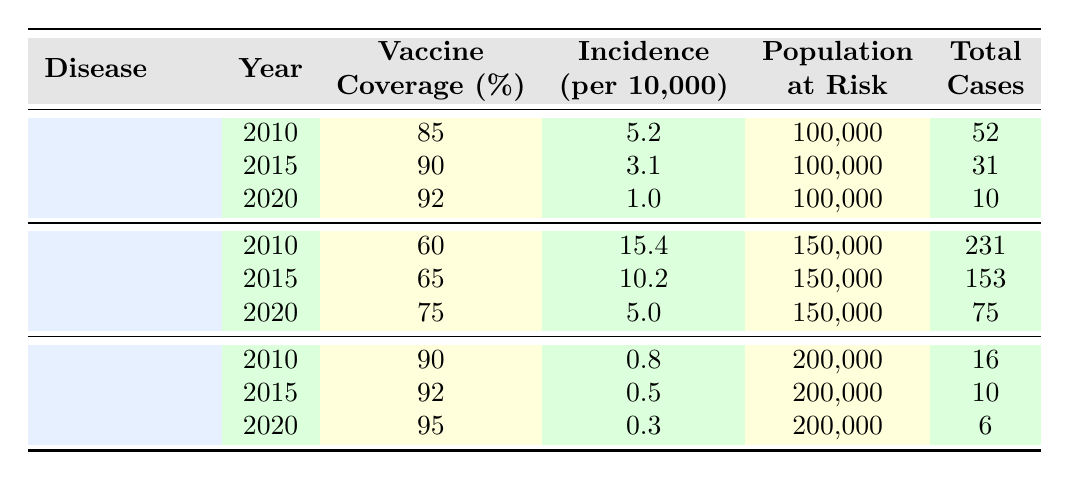What's the total number of measles cases in 2015? From the table, we can directly look at the row for measles in the year 2015, where we find the total cases listed as 31.
Answer: 31 What was the vaccine coverage percentage for influenza in 2020? The table indicates that the vaccine coverage percentage for influenza in 2020 is 75, as stated in the corresponding row of the table.
Answer: 75 What is the average incidence of Hepatitis B over the years 2010, 2015, and 2020? To find the average incidence of Hepatitis B, we sum up the incidences for the three years: (0.8 + 0.5 + 0.3) = 1.6. Then we divide by the number of years (3), which gives us 1.6 / 3 = 0.5333.
Answer: 0.5333 Was the incidence of measles in 2020 lower than in 2015? We can compare the incidence values for measles in 2015 (3.1) and 2020 (1.0). Since 1.0 is less than 3.1, the statement is true.
Answer: Yes What was the reduction in total cases of influenza from 2010 to 2020? The total cases of influenza in 2010 were 231 and in 2020 were 75. To find the reduction, we subtract the cases in 2020 from the cases in 2010: 231 - 75 = 156.
Answer: 156 